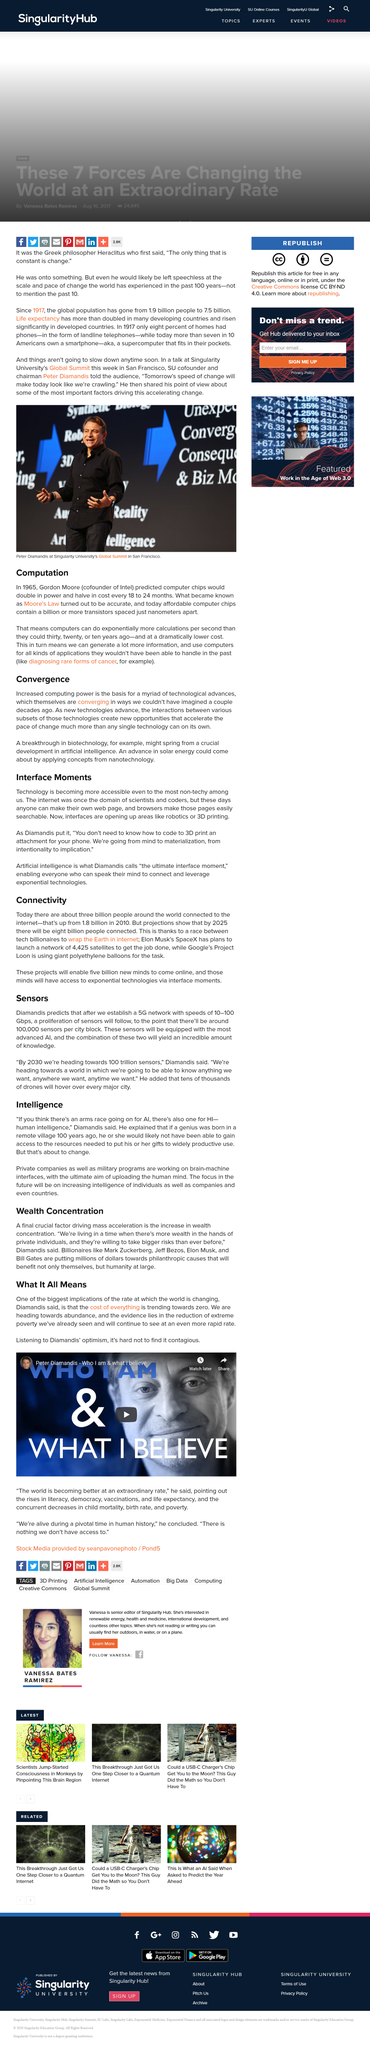Mention a couple of crucial points in this snapshot. The pursuit of artificial intelligence is not separate from the quest for human intelligence, as a parallel race is underway to achieve both. As mind continues to evolve and grow, it is destined to reach the stage of materialization, where physical forms will come into being and bring about a new era of existence. SpaceX aims to launch a total of 4,425 satellites into orbit, in order to provide widespread internet coverage to the global population. The talk is being held in San Francisco. Five billion more individuals will have access to the internet as a result of being able to come online. 